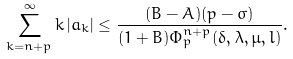<formula> <loc_0><loc_0><loc_500><loc_500>\sum _ { k = n + p } ^ { \infty } k \left | a _ { k } \right | \leq \frac { ( B - A ) ( p - \sigma ) } { ( 1 + B ) \Phi _ { p } ^ { n + p } ( \delta , \lambda , \mu , l ) } .</formula> 